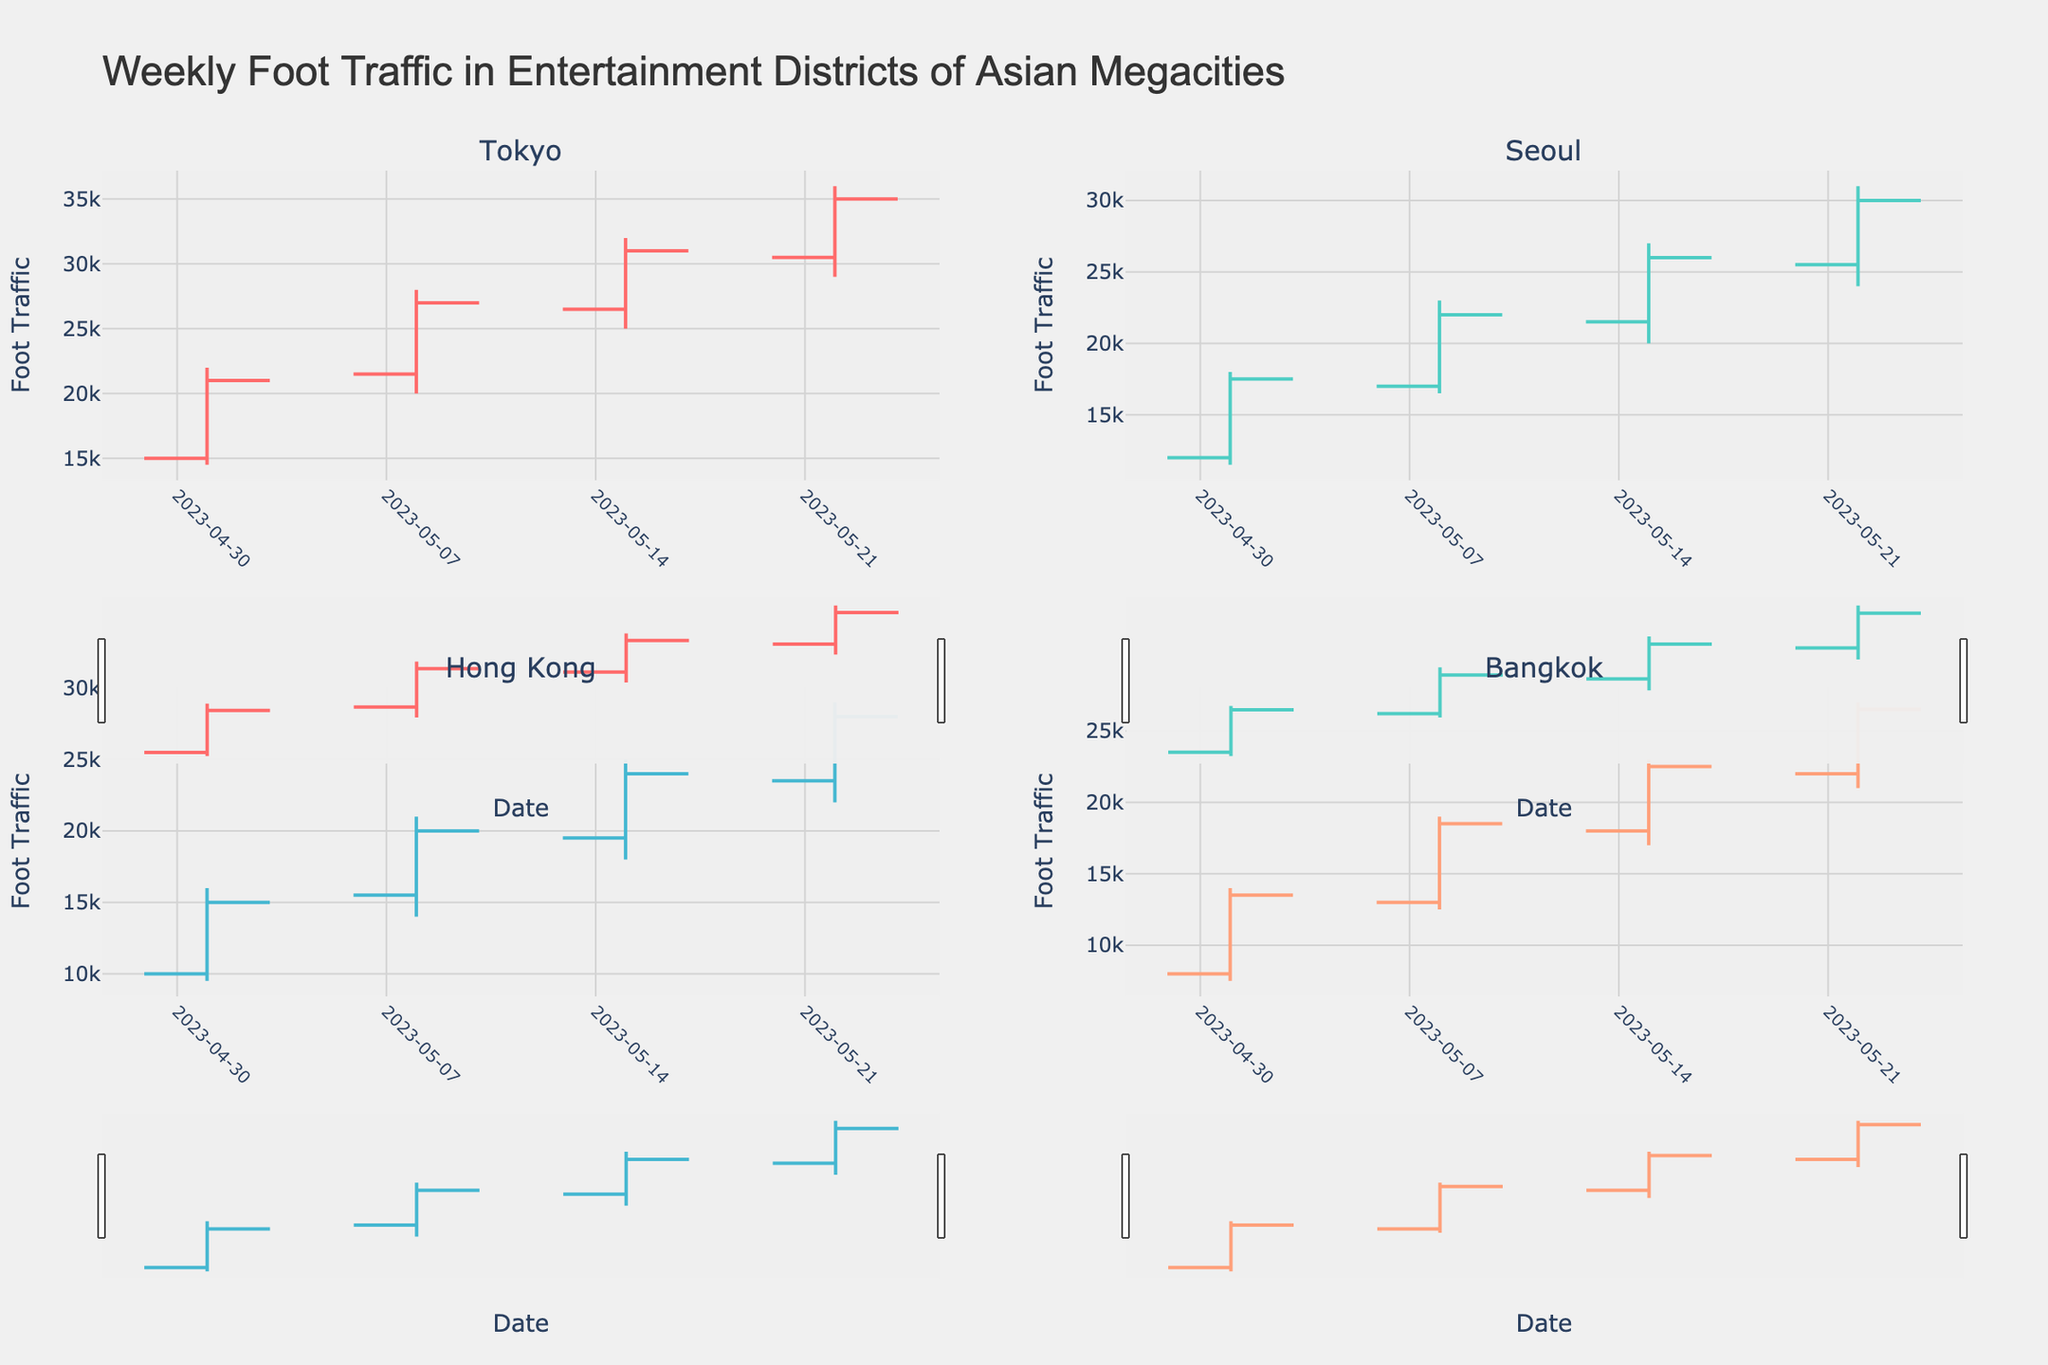What's the highest foot traffic recorded in Seoul's Gangnam district? The highest value in the OHLC chart for Seoul's Gangnam district corresponds to the 'High' value. Refer to the subplot for Gangnam and find the highest 'High' value across all weeks.
Answer: 31,000 What's the median 'Open' value for Bangkok's Sukhumvit district over the weeks? To find the median, list all 'Open' values for Sukhumvit: 8,000, 13,000, 18,000, 22,000. With an even number of values, calculate the average of the middle two: (13,000 + 18,000)/2 = 15,500.
Answer: 15,500 Did the foot traffic in Tokyo's Shibuya district increase each week? Check the closing foot traffic values for each week: 21,000, 27,000, 31,000, 35,000. Since each closing value is higher than the previous one, foot traffic increased each week.
Answer: Yes Which district had the highest closing foot traffic on May 22nd? Compare the closing foot traffic values across all districts on May 22nd. Shibuya: 35,000; Gangnam: 30,000; Lan Kwai Fong: 28,000; Sukhumvit: 26,500.
Answer: Shibuya What's the average closing foot traffic in Hong Kong's Lan Kwai Fong district over the listed weeks? List the closing foot traffic values for Lan Kwai Fong: 15,000, 20,000, 24,000, 28,000. Calculate the average: (15,000 + 20,000 + 24,000 + 28,000)/4 = 21,750.
Answer: 21,750 Is the increase in 'High' values for Bangkok's Sukhumvit district consistent over the weeks? Compare the 'High' values over the weeks for Sukhumvit: 14,000, 19,000, 23,000, 27,000. Subtract successive weeks (19,000-14,000=5,000; 23,000-19,000=4,000; 27,000-23,000=4,000). The increases are not consistent as the first difference is 5,000 but the others are 4,000.
Answer: No What's the average range of foot traffic (High - Low) in the Tokyo's Shibuya district? Calculate the range for Shibuya each week: (22,000-14,500)=7,500, (28,000-20,000)=8,000, (32,000-25,000)=7,000, (36,000-29,000)=7,000. Average these values: (7,500 + 8,000 + 7,000 + 7,000)/4 = 7,375.
Answer: 7,375 Which district showed the highest growth in 'Open' values from the start to the end of the period? Compare the change in 'Open' values from May 1st to May 22nd for each district. Tokyo: (30,500-15,000)=15,500; Seoul: (25,500-12,000)=13,500; HK: (23,500-10,000)=13,500; Bangkok: (22,000-8,000)=14,000.
Answer: Tokyo What pattern can be observed in the closing foot traffic of Seoul's Gangnam district? Examine Gangnam's closing values: 17,500, 22,000, 26,000, 30,000. It's apparent that foot traffic shows an increasing trend every week.
Answer: Increasing trend 